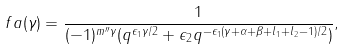<formula> <loc_0><loc_0><loc_500><loc_500>\ f a ( \gamma ) = \frac { 1 } { ( - 1 ) ^ { m ^ { \prime \prime } \gamma } ( q ^ { \epsilon _ { 1 } \gamma / 2 } + \epsilon _ { 2 } q ^ { - \epsilon _ { 1 } ( \gamma + \alpha + \beta + l _ { 1 } + l _ { 2 } - 1 ) / 2 } ) } ,</formula> 